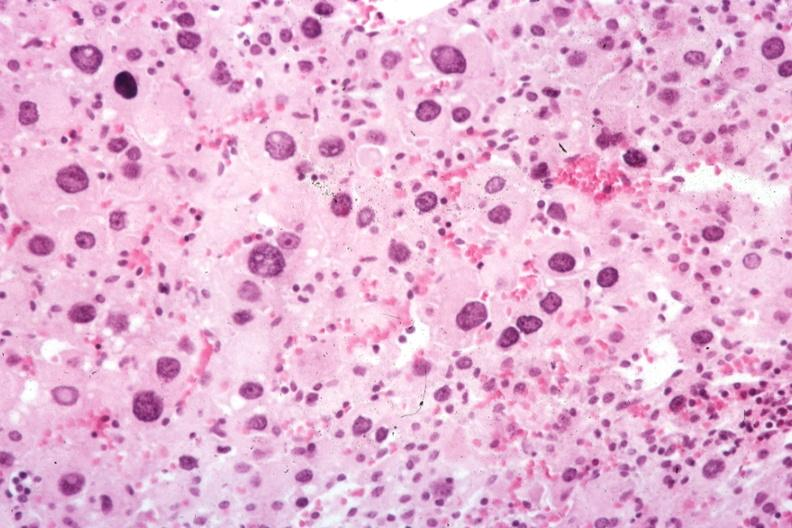s carcinomatosis endometrium primary present?
Answer the question using a single word or phrase. No 